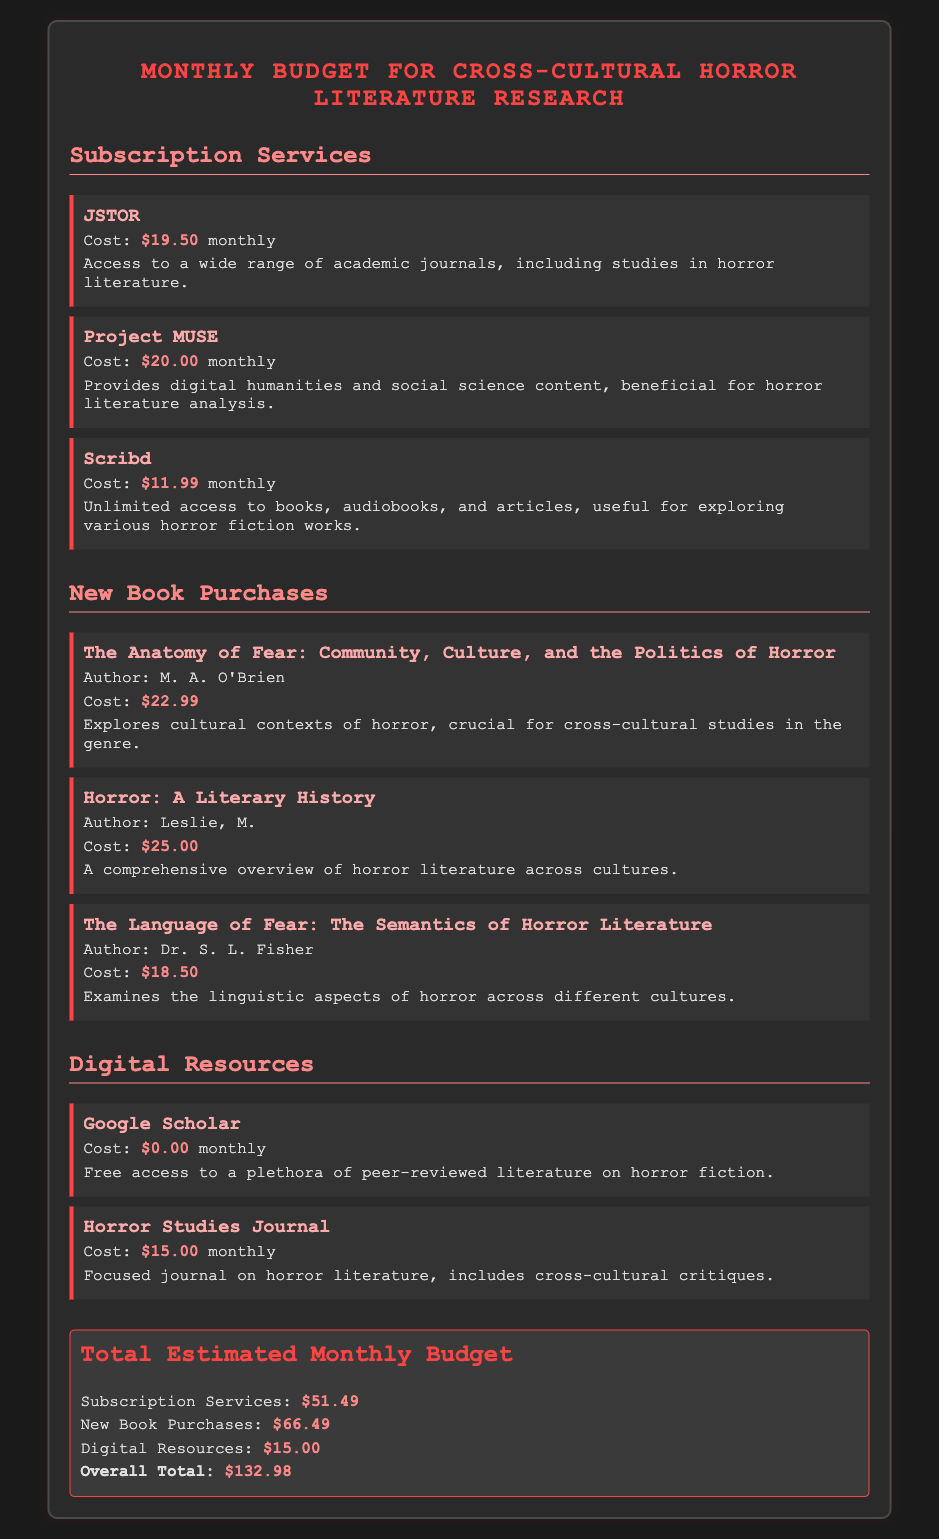What is the total cost for Subscription Services? The total cost for Subscription Services is calculated by adding the individual costs of JSTOR, Project MUSE, and Scribd, which is $19.50 + $20.00 + $11.99 = $51.49.
Answer: $51.49 How much does the book "Horror: A Literary History" cost? The cost of "Horror: A Literary History" is explicitly stated in the document as $25.00.
Answer: $25.00 What is the monthly cost of Google Scholar? The document indicates that Google Scholar has a cost of $0.00 monthly, which means it is free.
Answer: $0.00 How many new books are listed in the budget? The budget includes three new book purchases, which can be counted from the document.
Answer: 3 What is the overall total estimated monthly budget? The overall total is the sum of all categories, which is clearly stated as $132.98 in the total section of the document.
Answer: $132.98 What subscription service costs the most? Among the subscription services, Project MUSE has the highest cost, which is stated at $20.00 monthly.
Answer: Project MUSE How much does the Horror Studies Journal cost per month? The document specifies the monthly cost of the Horror Studies Journal as $15.00.
Answer: $15.00 Which digital resource is free? The document clearly states that Google Scholar has a cost of $0.00, indicating it is a free digital resource.
Answer: Google Scholar What is the total cost for New Book Purchases? The total for New Book Purchases is calculated by adding the costs of the listed books, which totals $66.49 as indicated in the document.
Answer: $66.49 